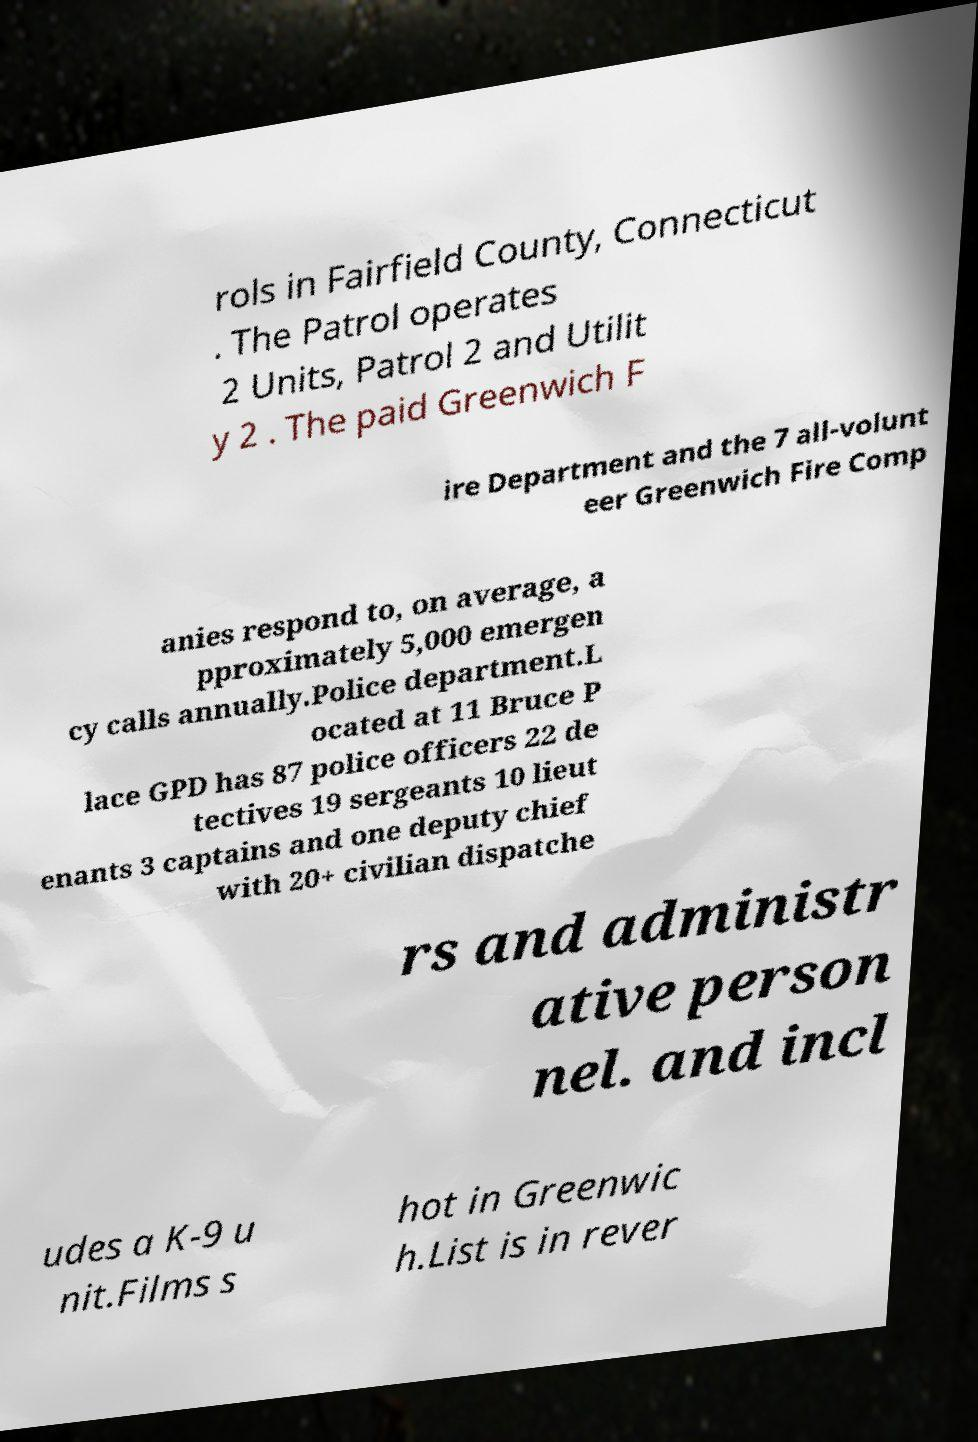Can you accurately transcribe the text from the provided image for me? rols in Fairfield County, Connecticut . The Patrol operates 2 Units, Patrol 2 and Utilit y 2 . The paid Greenwich F ire Department and the 7 all-volunt eer Greenwich Fire Comp anies respond to, on average, a pproximately 5,000 emergen cy calls annually.Police department.L ocated at 11 Bruce P lace GPD has 87 police officers 22 de tectives 19 sergeants 10 lieut enants 3 captains and one deputy chief with 20+ civilian dispatche rs and administr ative person nel. and incl udes a K-9 u nit.Films s hot in Greenwic h.List is in rever 